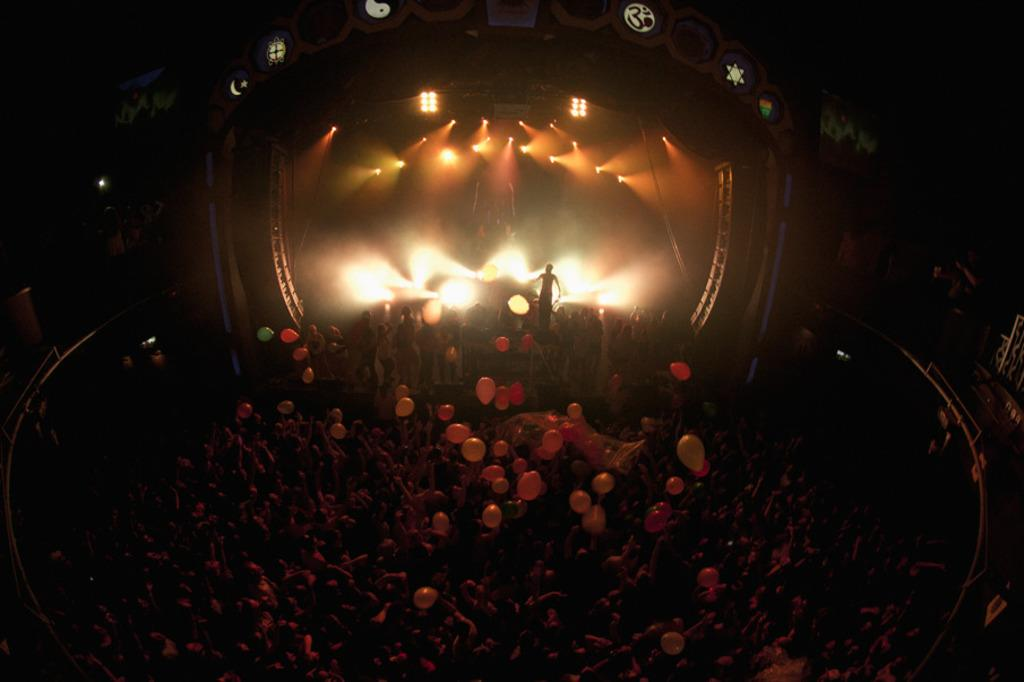What is happening in the image? There are people standing in the image, and one person is standing on a stage. What can be seen in the background of the image? There are lights visible in the image. What decorations are present in the image? There are balloons present in the image. What type of dress is the person on the stage wearing? There is no information about the person's dress in the image. 